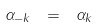<formula> <loc_0><loc_0><loc_500><loc_500>\alpha _ { - k } \ = \ \alpha _ { k }</formula> 